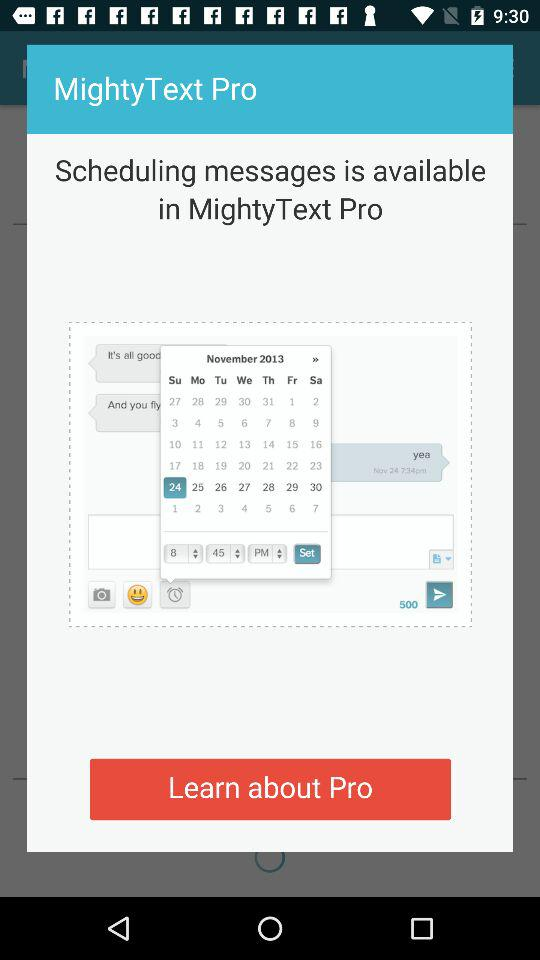What is the set time? The set time is 8:45 p.m. 